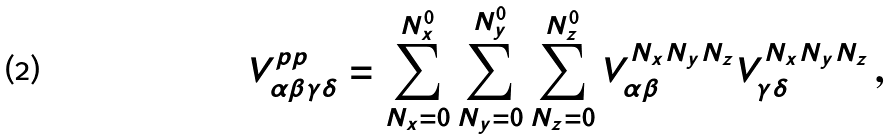<formula> <loc_0><loc_0><loc_500><loc_500>V _ { \alpha \beta \gamma \delta } ^ { p p } = \sum _ { N _ { x } = 0 } ^ { N _ { x } ^ { 0 } } \sum _ { N _ { y } = 0 } ^ { N _ { y } ^ { 0 } } \sum _ { N _ { z } = 0 } ^ { N _ { z } ^ { 0 } } V _ { \alpha \beta } ^ { N _ { x } N _ { y } N _ { z } } V _ { \gamma \delta } ^ { N _ { x } N _ { y } N _ { z } } \, ,</formula> 